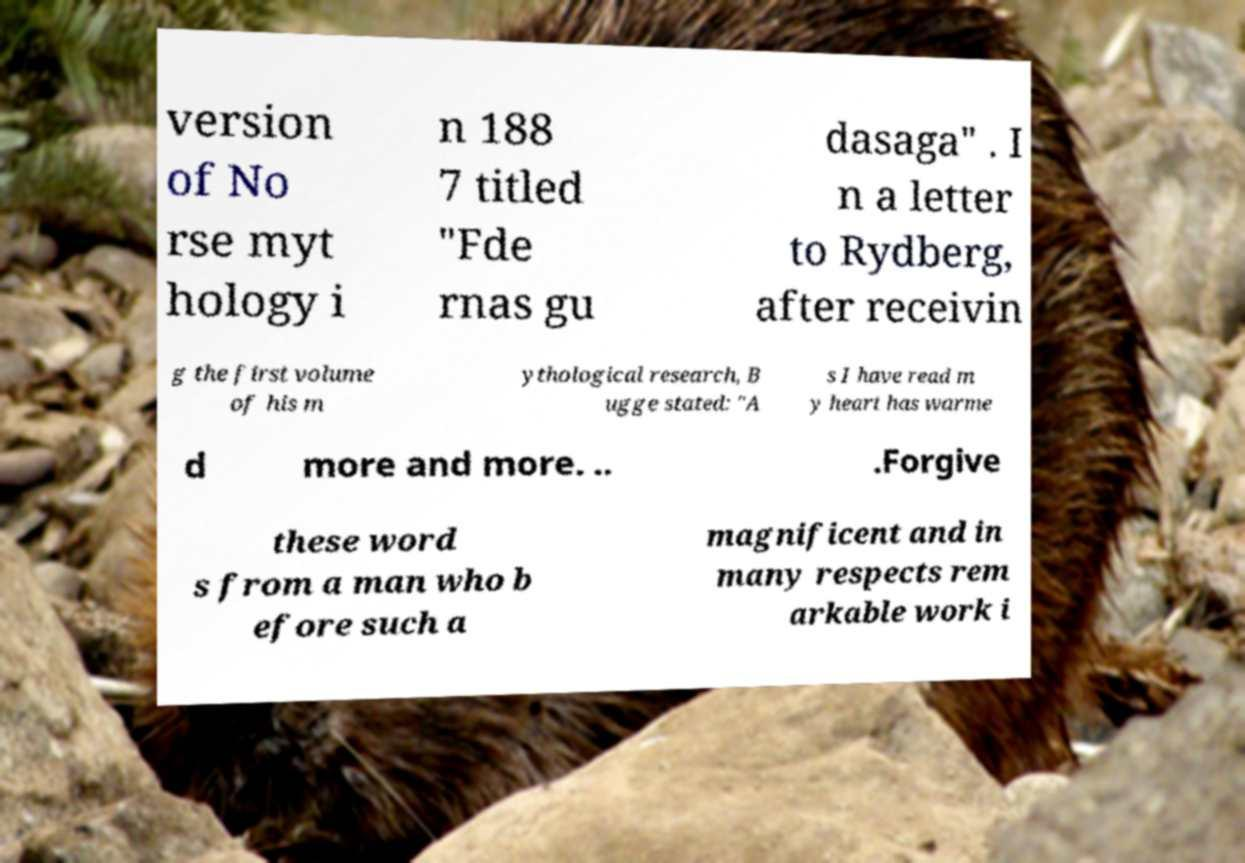For documentation purposes, I need the text within this image transcribed. Could you provide that? version of No rse myt hology i n 188 7 titled "Fde rnas gu dasaga" . I n a letter to Rydberg, after receivin g the first volume of his m ythological research, B ugge stated: "A s I have read m y heart has warme d more and more. .. .Forgive these word s from a man who b efore such a magnificent and in many respects rem arkable work i 